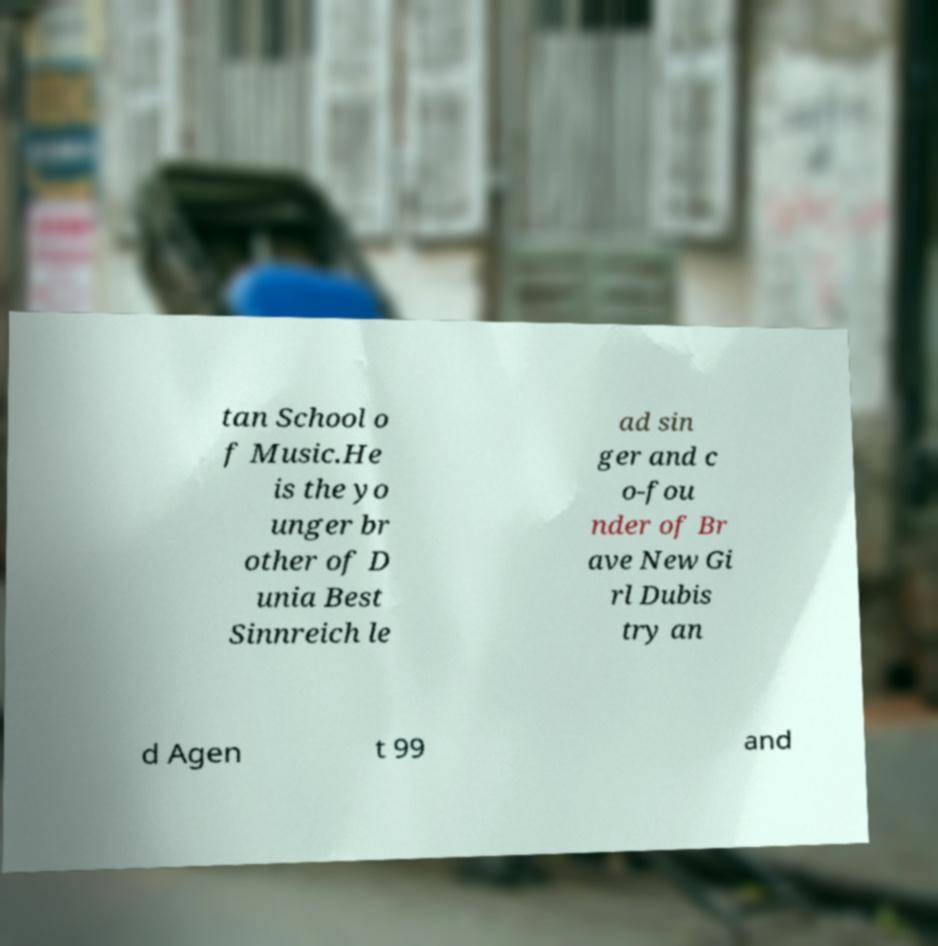For documentation purposes, I need the text within this image transcribed. Could you provide that? tan School o f Music.He is the yo unger br other of D unia Best Sinnreich le ad sin ger and c o-fou nder of Br ave New Gi rl Dubis try an d Agen t 99 and 